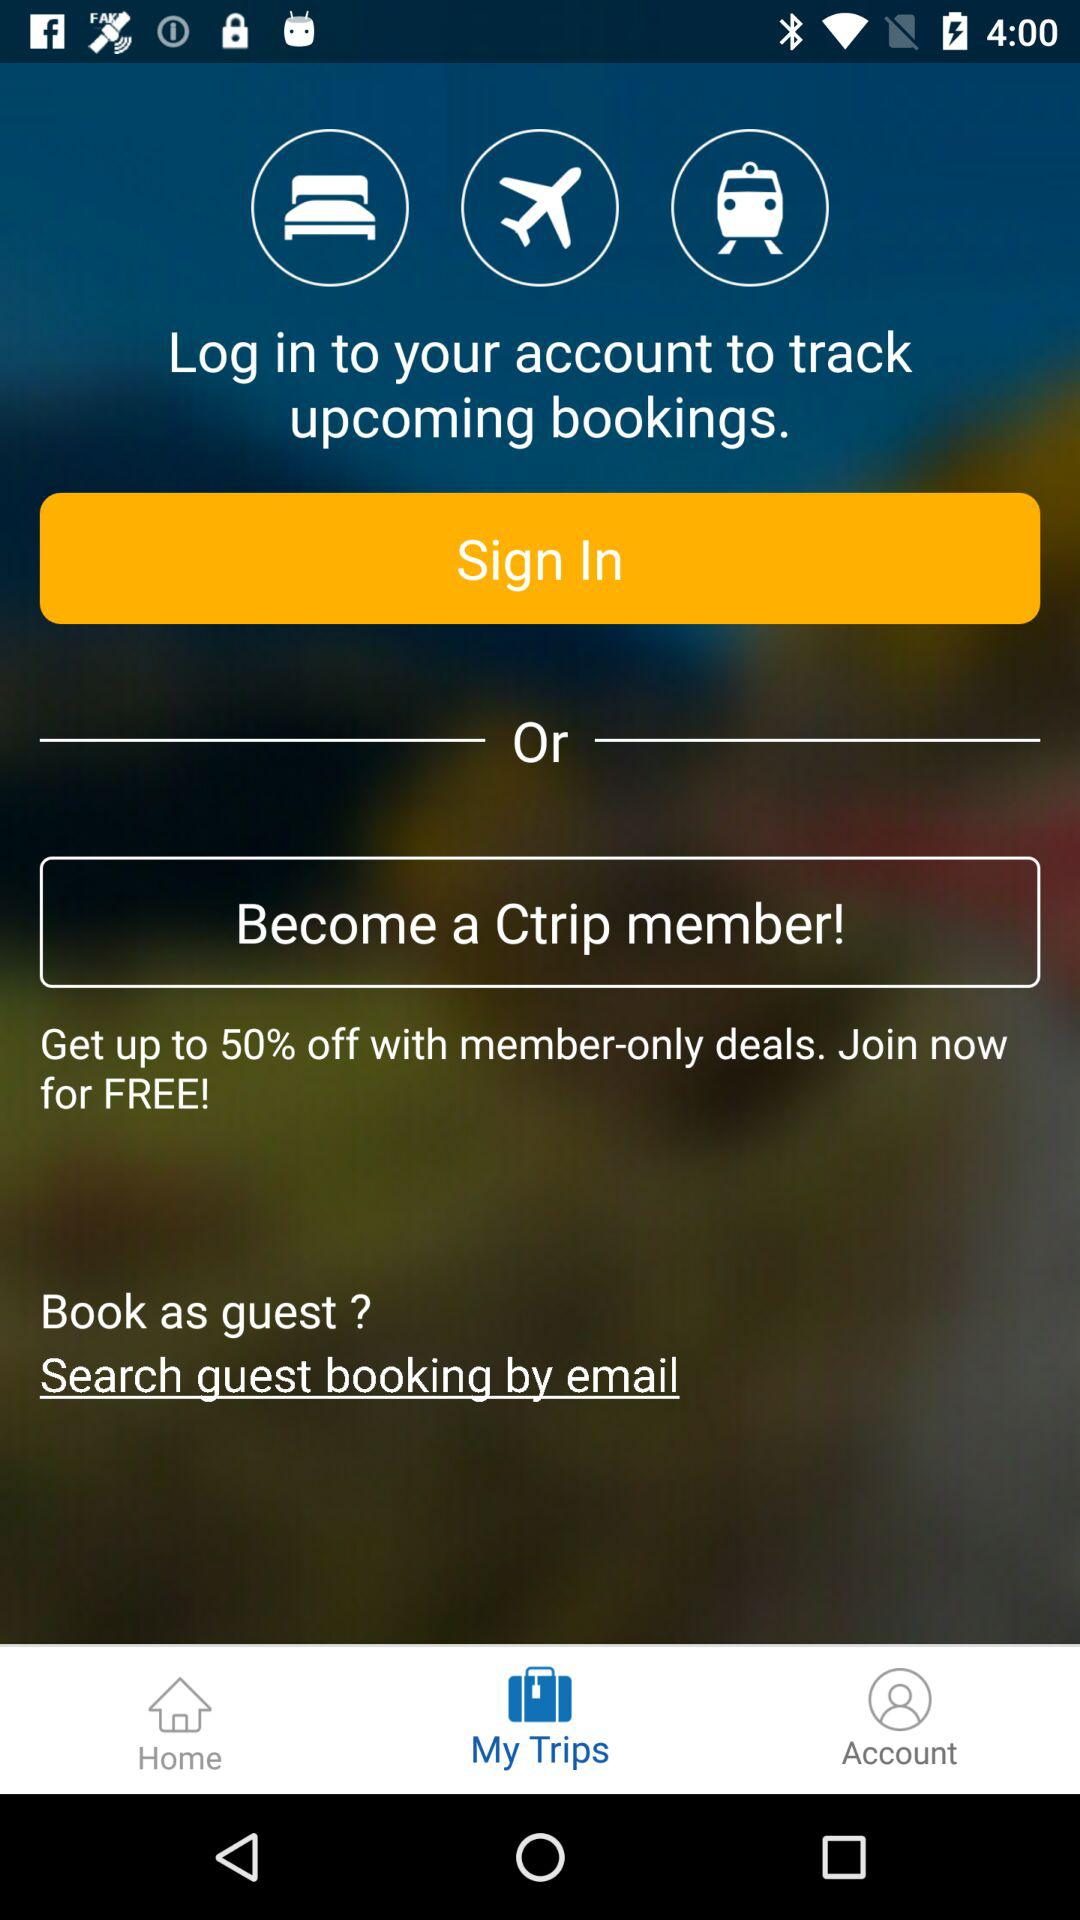What is the name of the application? The name of the application is "Ctrip". 